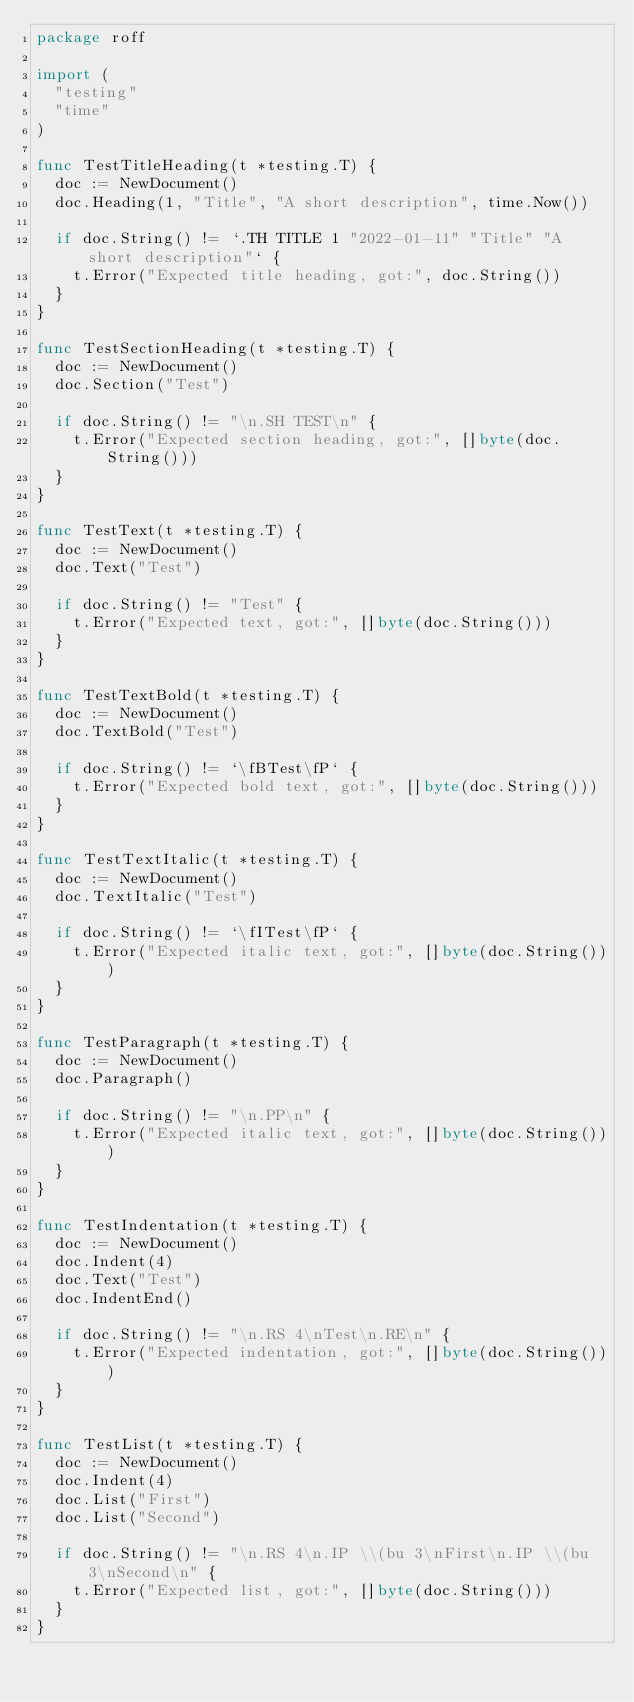<code> <loc_0><loc_0><loc_500><loc_500><_Go_>package roff

import (
	"testing"
	"time"
)

func TestTitleHeading(t *testing.T) {
	doc := NewDocument()
	doc.Heading(1, "Title", "A short description", time.Now())

	if doc.String() != `.TH TITLE 1 "2022-01-11" "Title" "A short description"` {
		t.Error("Expected title heading, got:", doc.String())
	}
}

func TestSectionHeading(t *testing.T) {
	doc := NewDocument()
	doc.Section("Test")

	if doc.String() != "\n.SH TEST\n" {
		t.Error("Expected section heading, got:", []byte(doc.String()))
	}
}

func TestText(t *testing.T) {
	doc := NewDocument()
	doc.Text("Test")

	if doc.String() != "Test" {
		t.Error("Expected text, got:", []byte(doc.String()))
	}
}

func TestTextBold(t *testing.T) {
	doc := NewDocument()
	doc.TextBold("Test")

	if doc.String() != `\fBTest\fP` {
		t.Error("Expected bold text, got:", []byte(doc.String()))
	}
}

func TestTextItalic(t *testing.T) {
	doc := NewDocument()
	doc.TextItalic("Test")

	if doc.String() != `\fITest\fP` {
		t.Error("Expected italic text, got:", []byte(doc.String()))
	}
}

func TestParagraph(t *testing.T) {
	doc := NewDocument()
	doc.Paragraph()

	if doc.String() != "\n.PP\n" {
		t.Error("Expected italic text, got:", []byte(doc.String()))
	}
}

func TestIndentation(t *testing.T) {
	doc := NewDocument()
	doc.Indent(4)
	doc.Text("Test")
	doc.IndentEnd()

	if doc.String() != "\n.RS 4\nTest\n.RE\n" {
		t.Error("Expected indentation, got:", []byte(doc.String()))
	}
}

func TestList(t *testing.T) {
	doc := NewDocument()
	doc.Indent(4)
	doc.List("First")
	doc.List("Second")

	if doc.String() != "\n.RS 4\n.IP \\(bu 3\nFirst\n.IP \\(bu 3\nSecond\n" {
		t.Error("Expected list, got:", []byte(doc.String()))
	}
}
</code> 